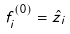Convert formula to latex. <formula><loc_0><loc_0><loc_500><loc_500>\ f _ { i } ^ { ( 0 ) } = \hat { z } _ { i }</formula> 